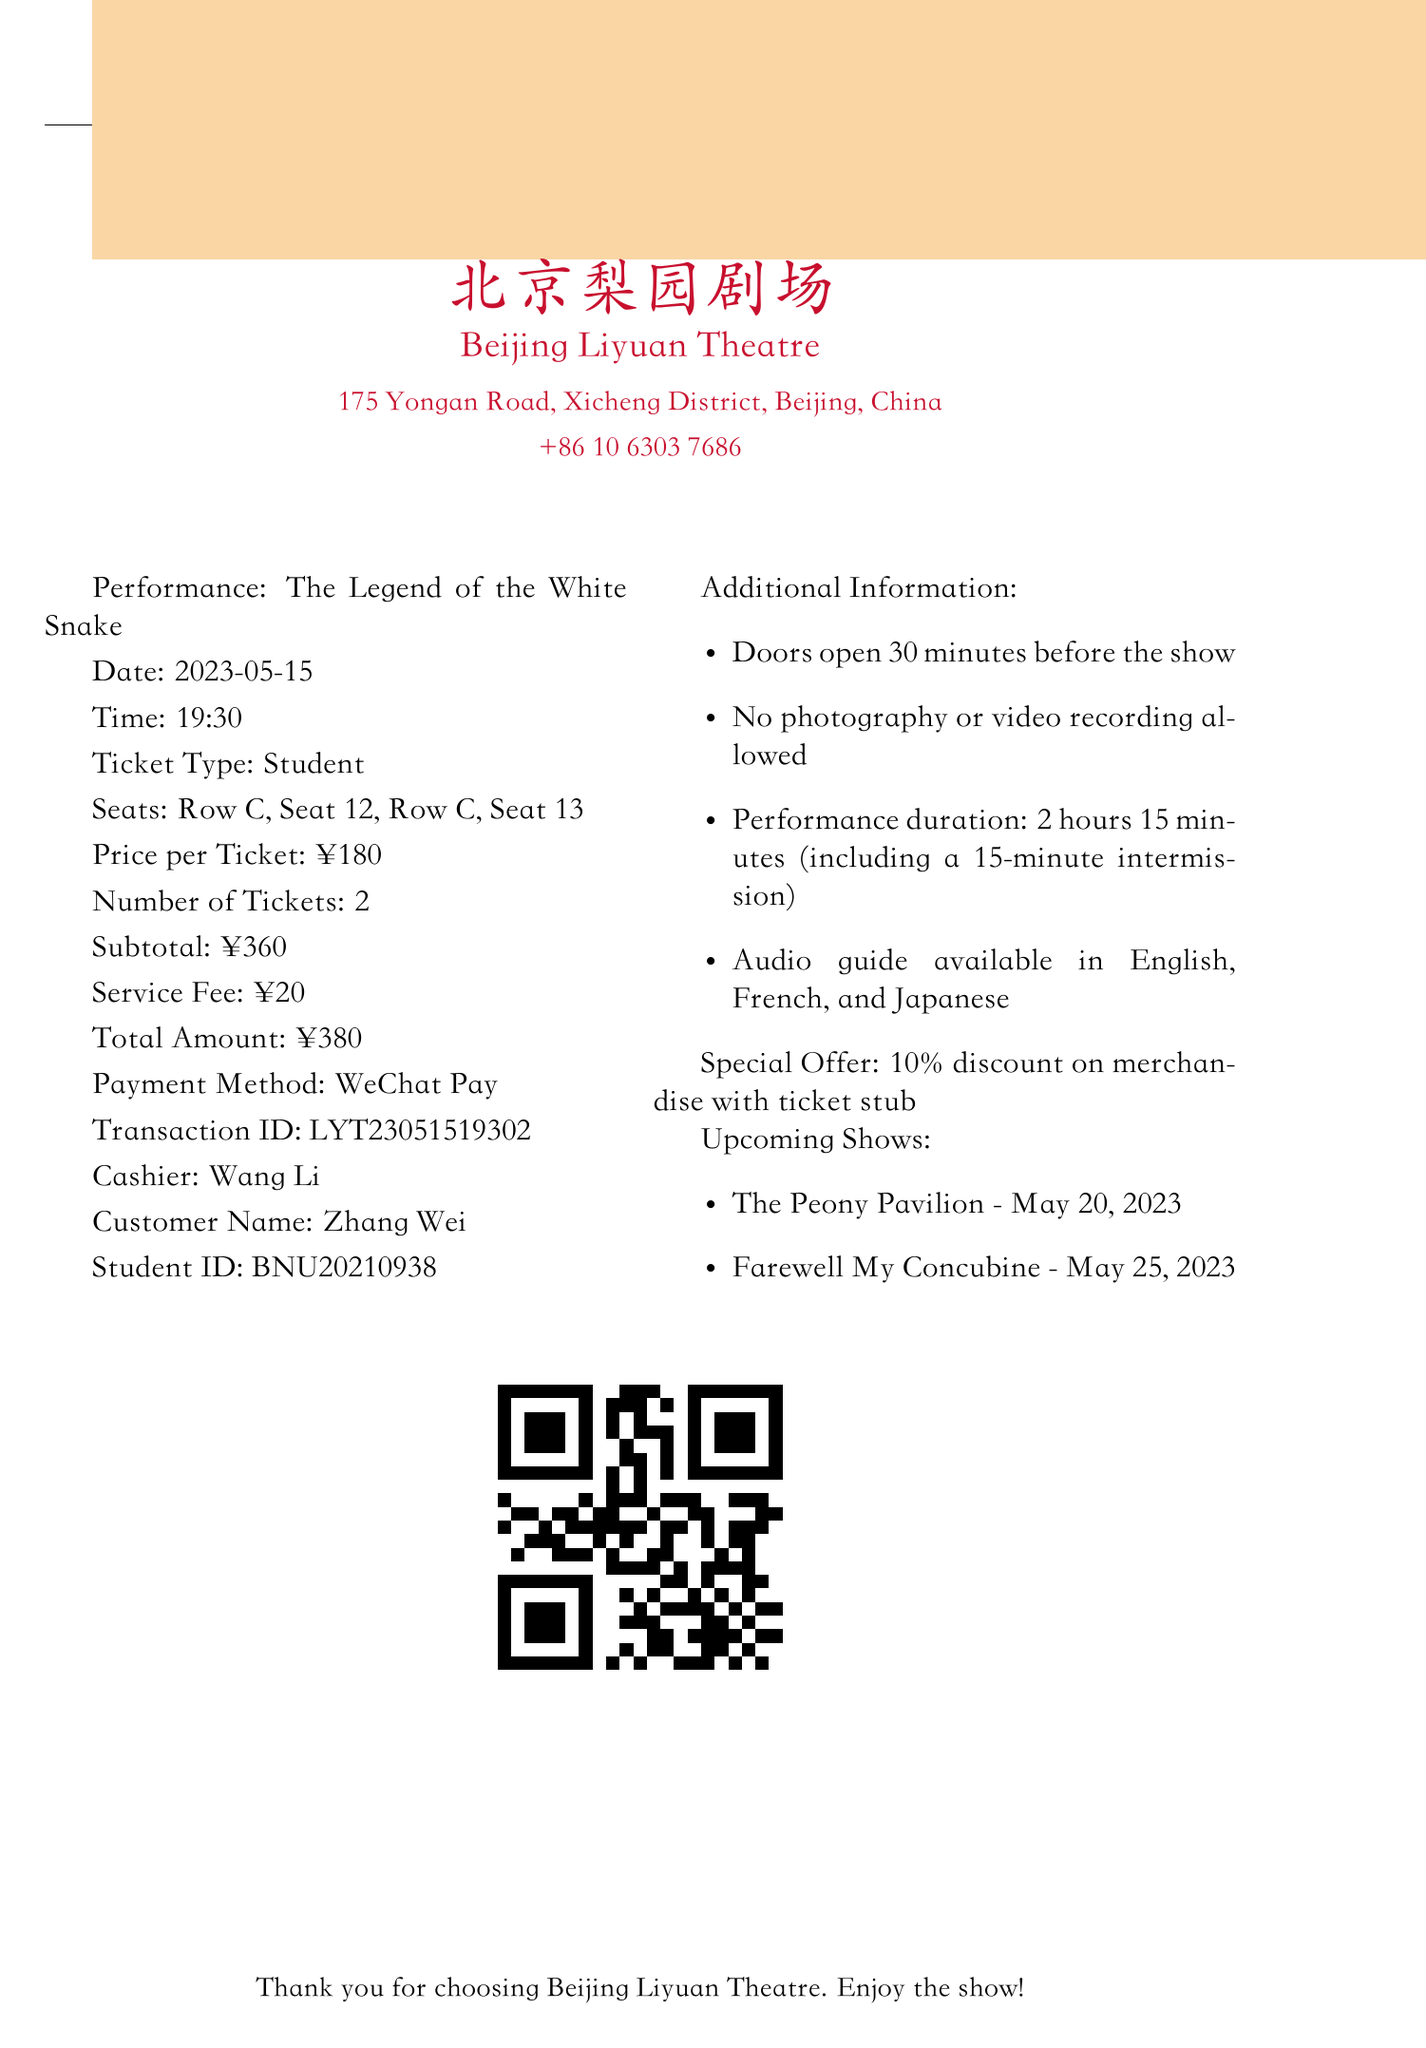What is the name of the theater? The theater name is indicated at the top of the receipt.
Answer: Beijing Liyuan Theatre What is the date of the performance? The document lists the performance date as part of the details.
Answer: 2023-05-15 How much does each ticket cost? The price per ticket is specified in the ticket details section.
Answer: ¥180 What seat numbers are assigned? The receipt provides specific seating information for the tickets purchased.
Answer: Row C, Seat 12, Row C, Seat 13 What is the total amount paid? The total amount combines tickets and service fee as stated in the receipt.
Answer: ¥380 Who is the cashier for this transaction? The cashier's name is mentioned next to the transaction details.
Answer: Wang Li How long is the performance? The duration of the performance is mentioned in the additional information section.
Answer: 2 hours 15 minutes What is the special offer mentioned? The special offer is specified under a dedicated section within the document.
Answer: 10% discount on merchandise with ticket stub What method was used for payment? The payment method is listed with the financial transaction details.
Answer: WeChat Pay 